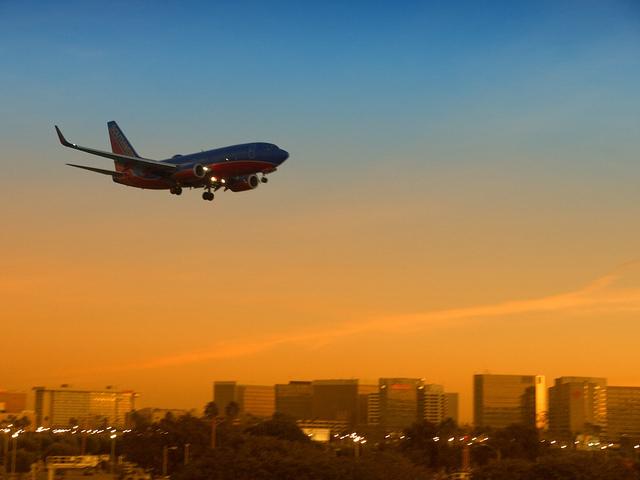What is the color of the plane?
Quick response, please. Red and blue. Where is the skyline?
Answer briefly. Lower third of picture. Where is the plane?
Give a very brief answer. Sky. What are they flying over?
Quick response, please. City. Is the plane going to land soon?
Be succinct. Yes. Is this photo in color?
Be succinct. Yes. 